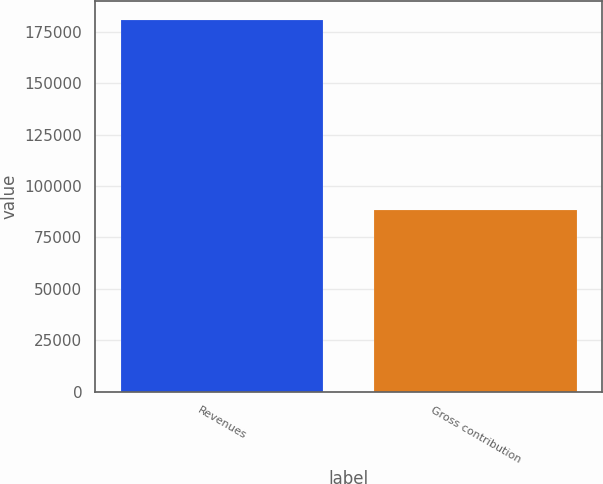<chart> <loc_0><loc_0><loc_500><loc_500><bar_chart><fcel>Revenues<fcel>Gross contribution<nl><fcel>180788<fcel>88164<nl></chart> 